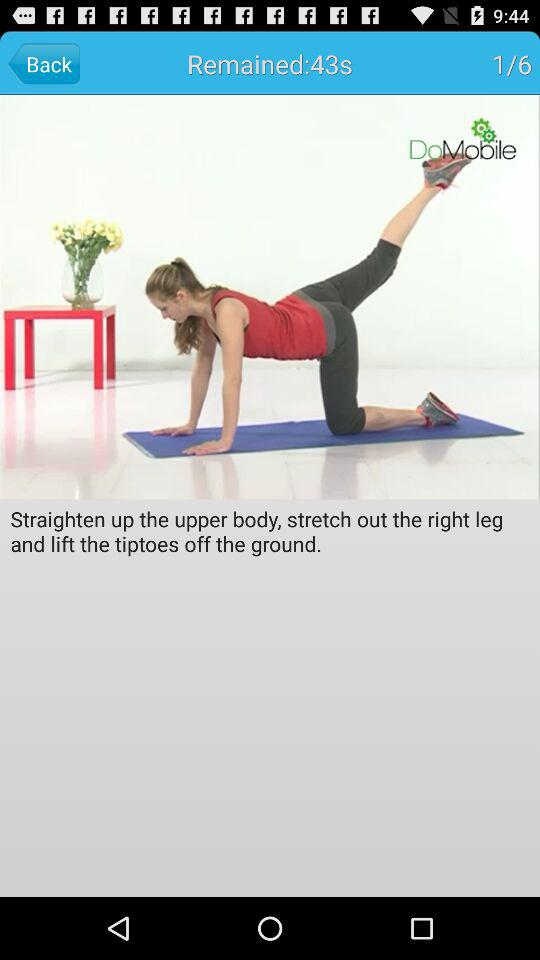What is the total number of exercises? The total number of exercises is 6. 